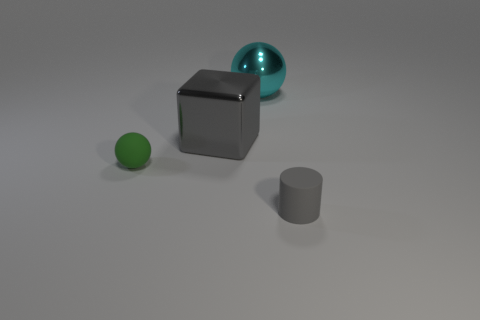There is a metal ball that is the same size as the gray metal block; what color is it?
Offer a very short reply. Cyan. Is there a metal object right of the ball that is on the right side of the large gray thing?
Keep it short and to the point. No. What number of cubes are big metallic things or large gray matte things?
Provide a succinct answer. 1. There is a gray object behind the small rubber object that is to the right of the gray object behind the matte ball; how big is it?
Keep it short and to the point. Large. There is a gray rubber cylinder; are there any gray metal blocks to the left of it?
Provide a short and direct response. Yes. What is the shape of the matte object that is the same color as the cube?
Your response must be concise. Cylinder. How many objects are balls that are in front of the big gray block or tiny cyan matte cylinders?
Offer a very short reply. 1. What size is the green ball that is the same material as the small cylinder?
Make the answer very short. Small. There is a green sphere; is it the same size as the gray object in front of the green matte object?
Provide a short and direct response. Yes. There is a thing that is both behind the small green thing and on the left side of the cyan metal object; what is its color?
Give a very brief answer. Gray. 